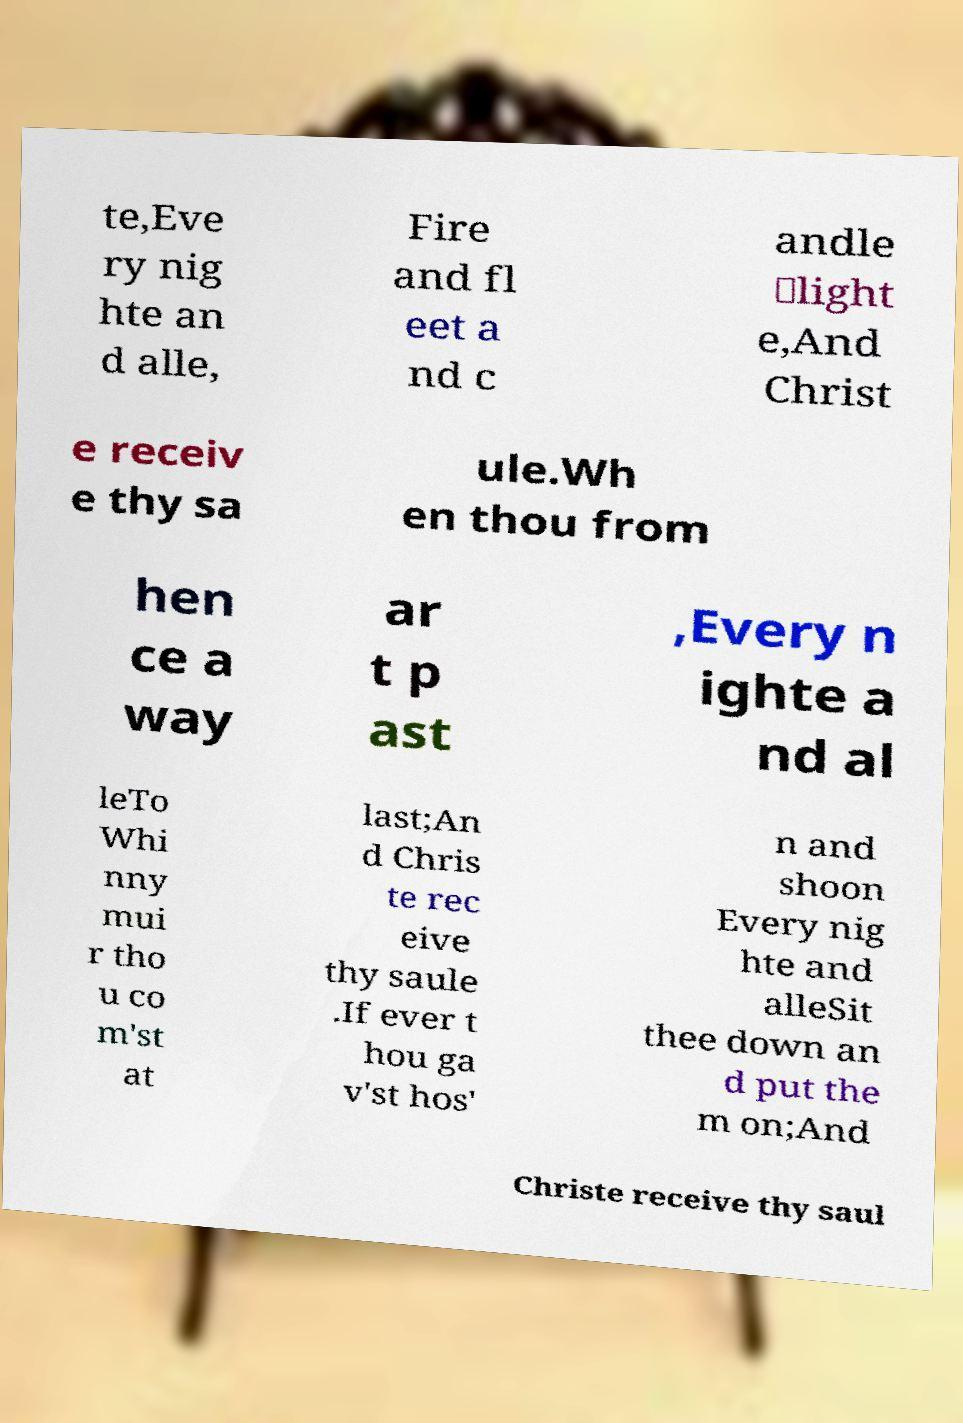Please read and relay the text visible in this image. What does it say? te,Eve ry nig hte an d alle, Fire and fl eet a nd c andle ‑light e,And Christ e receiv e thy sa ule.Wh en thou from hen ce a way ar t p ast ,Every n ighte a nd al leTo Whi nny mui r tho u co m'st at last;An d Chris te rec eive thy saule .If ever t hou ga v'st hos' n and shoon Every nig hte and alleSit thee down an d put the m on;And Christe receive thy saul 